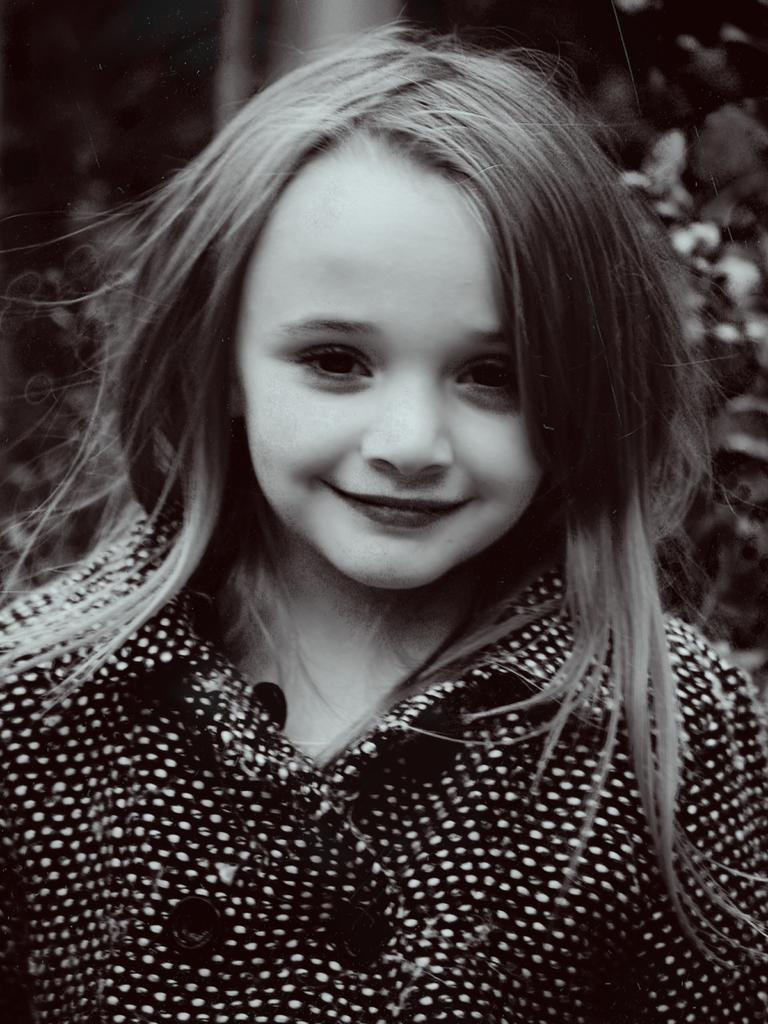Who is the main subject in the foreground of the image? There is a girl present in the foreground of the image. What can be observed about the background of the image? The background of the image is blurry. Are there any birds trapped in the quicksand in the image? There is no quicksand or birds present in the image. Can you see any ghosts in the background of the image? There are no ghosts present in the image; the background is blurry, but no supernatural entities are visible. 